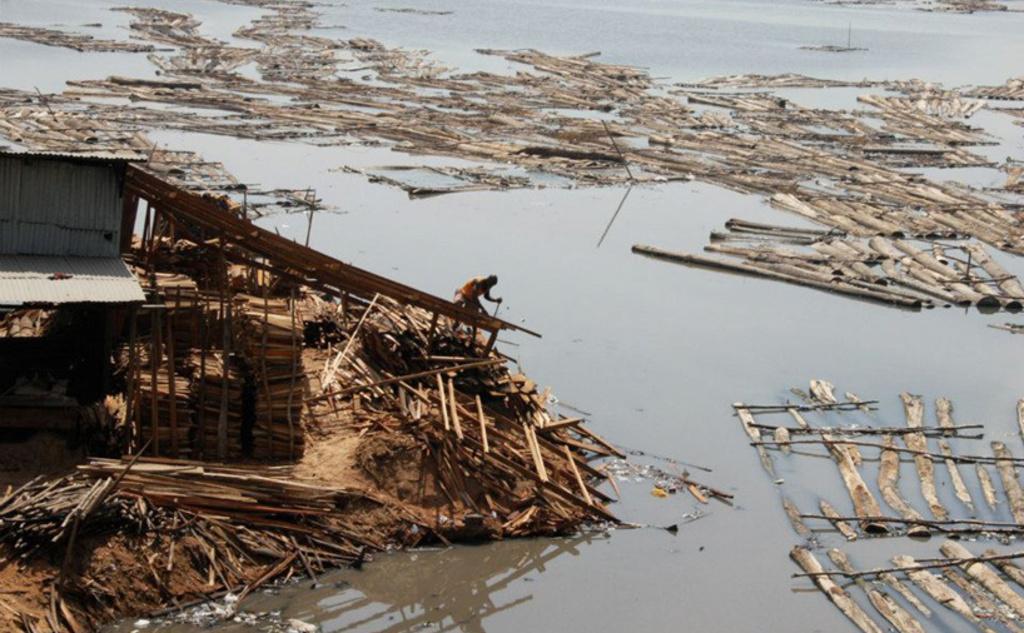Can you describe this image briefly? On the left side of the image there is a collapsed building. There are roofs, many wooden pieces and also there is a man. And on the right side of the image there is water with wooden logs and pieces. 